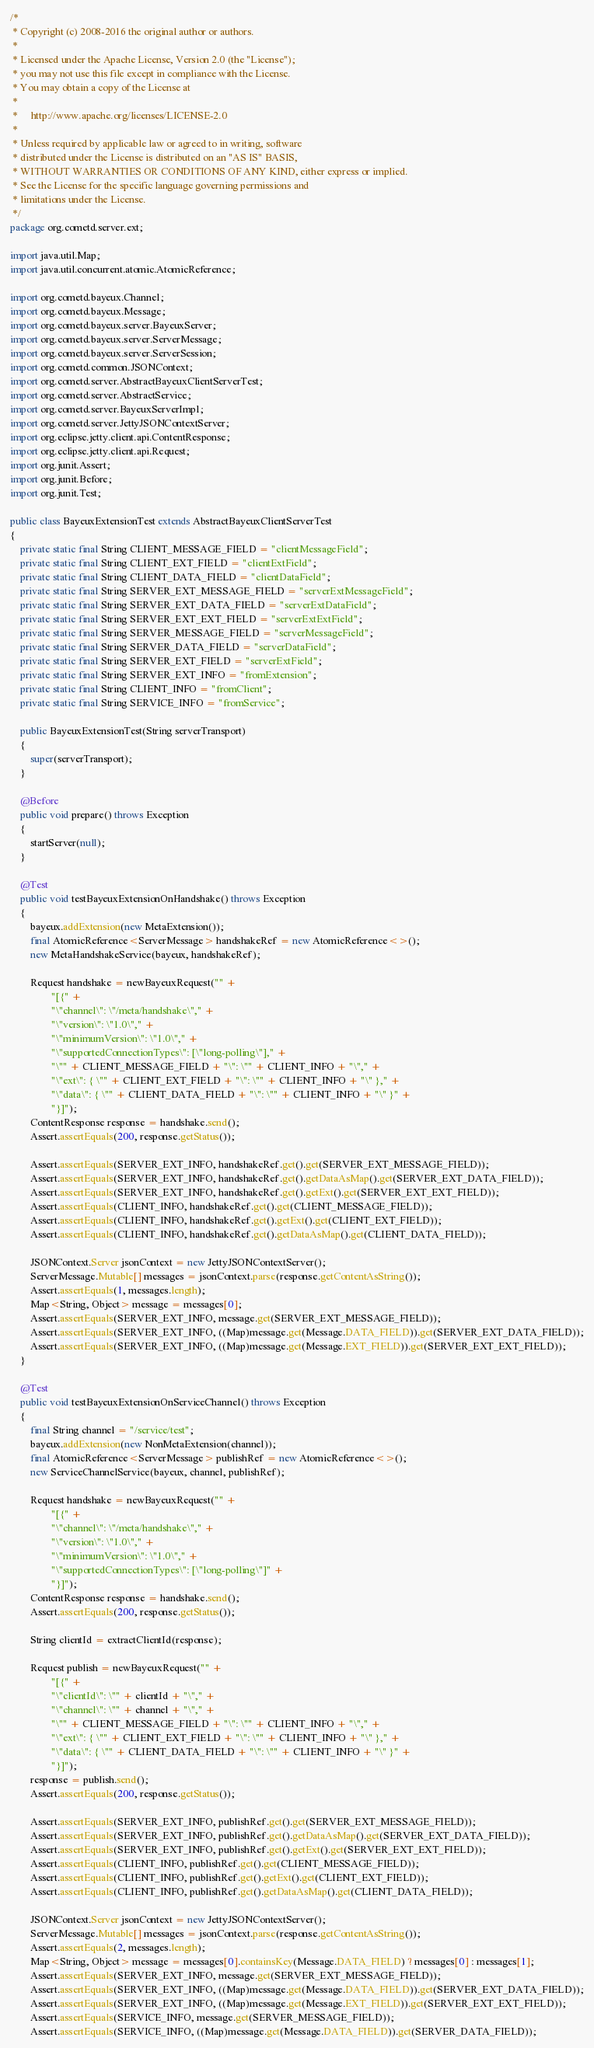Convert code to text. <code><loc_0><loc_0><loc_500><loc_500><_Java_>/*
 * Copyright (c) 2008-2016 the original author or authors.
 *
 * Licensed under the Apache License, Version 2.0 (the "License");
 * you may not use this file except in compliance with the License.
 * You may obtain a copy of the License at
 *
 *     http://www.apache.org/licenses/LICENSE-2.0
 *
 * Unless required by applicable law or agreed to in writing, software
 * distributed under the License is distributed on an "AS IS" BASIS,
 * WITHOUT WARRANTIES OR CONDITIONS OF ANY KIND, either express or implied.
 * See the License for the specific language governing permissions and
 * limitations under the License.
 */
package org.cometd.server.ext;

import java.util.Map;
import java.util.concurrent.atomic.AtomicReference;

import org.cometd.bayeux.Channel;
import org.cometd.bayeux.Message;
import org.cometd.bayeux.server.BayeuxServer;
import org.cometd.bayeux.server.ServerMessage;
import org.cometd.bayeux.server.ServerSession;
import org.cometd.common.JSONContext;
import org.cometd.server.AbstractBayeuxClientServerTest;
import org.cometd.server.AbstractService;
import org.cometd.server.BayeuxServerImpl;
import org.cometd.server.JettyJSONContextServer;
import org.eclipse.jetty.client.api.ContentResponse;
import org.eclipse.jetty.client.api.Request;
import org.junit.Assert;
import org.junit.Before;
import org.junit.Test;

public class BayeuxExtensionTest extends AbstractBayeuxClientServerTest
{
    private static final String CLIENT_MESSAGE_FIELD = "clientMessageField";
    private static final String CLIENT_EXT_FIELD = "clientExtField";
    private static final String CLIENT_DATA_FIELD = "clientDataField";
    private static final String SERVER_EXT_MESSAGE_FIELD = "serverExtMessageField";
    private static final String SERVER_EXT_DATA_FIELD = "serverExtDataField";
    private static final String SERVER_EXT_EXT_FIELD = "serverExtExtField";
    private static final String SERVER_MESSAGE_FIELD = "serverMessageField";
    private static final String SERVER_DATA_FIELD = "serverDataField";
    private static final String SERVER_EXT_FIELD = "serverExtField";
    private static final String SERVER_EXT_INFO = "fromExtension";
    private static final String CLIENT_INFO = "fromClient";
    private static final String SERVICE_INFO = "fromService";

    public BayeuxExtensionTest(String serverTransport)
    {
        super(serverTransport);
    }

    @Before
    public void prepare() throws Exception
    {
        startServer(null);
    }

    @Test
    public void testBayeuxExtensionOnHandshake() throws Exception
    {
        bayeux.addExtension(new MetaExtension());
        final AtomicReference<ServerMessage> handshakeRef = new AtomicReference<>();
        new MetaHandshakeService(bayeux, handshakeRef);

        Request handshake = newBayeuxRequest("" +
                "[{" +
                "\"channel\": \"/meta/handshake\"," +
                "\"version\": \"1.0\"," +
                "\"minimumVersion\": \"1.0\"," +
                "\"supportedConnectionTypes\": [\"long-polling\"]," +
                "\"" + CLIENT_MESSAGE_FIELD + "\": \"" + CLIENT_INFO + "\"," +
                "\"ext\": { \"" + CLIENT_EXT_FIELD + "\": \"" + CLIENT_INFO + "\" }," +
                "\"data\": { \"" + CLIENT_DATA_FIELD + "\": \"" + CLIENT_INFO + "\" }" +
                "}]");
        ContentResponse response = handshake.send();
        Assert.assertEquals(200, response.getStatus());

        Assert.assertEquals(SERVER_EXT_INFO, handshakeRef.get().get(SERVER_EXT_MESSAGE_FIELD));
        Assert.assertEquals(SERVER_EXT_INFO, handshakeRef.get().getDataAsMap().get(SERVER_EXT_DATA_FIELD));
        Assert.assertEquals(SERVER_EXT_INFO, handshakeRef.get().getExt().get(SERVER_EXT_EXT_FIELD));
        Assert.assertEquals(CLIENT_INFO, handshakeRef.get().get(CLIENT_MESSAGE_FIELD));
        Assert.assertEquals(CLIENT_INFO, handshakeRef.get().getExt().get(CLIENT_EXT_FIELD));
        Assert.assertEquals(CLIENT_INFO, handshakeRef.get().getDataAsMap().get(CLIENT_DATA_FIELD));

        JSONContext.Server jsonContext = new JettyJSONContextServer();
        ServerMessage.Mutable[] messages = jsonContext.parse(response.getContentAsString());
        Assert.assertEquals(1, messages.length);
        Map<String, Object> message = messages[0];
        Assert.assertEquals(SERVER_EXT_INFO, message.get(SERVER_EXT_MESSAGE_FIELD));
        Assert.assertEquals(SERVER_EXT_INFO, ((Map)message.get(Message.DATA_FIELD)).get(SERVER_EXT_DATA_FIELD));
        Assert.assertEquals(SERVER_EXT_INFO, ((Map)message.get(Message.EXT_FIELD)).get(SERVER_EXT_EXT_FIELD));
    }

    @Test
    public void testBayeuxExtensionOnServiceChannel() throws Exception
    {
        final String channel = "/service/test";
        bayeux.addExtension(new NonMetaExtension(channel));
        final AtomicReference<ServerMessage> publishRef = new AtomicReference<>();
        new ServiceChannelService(bayeux, channel, publishRef);

        Request handshake = newBayeuxRequest("" +
                "[{" +
                "\"channel\": \"/meta/handshake\"," +
                "\"version\": \"1.0\"," +
                "\"minimumVersion\": \"1.0\"," +
                "\"supportedConnectionTypes\": [\"long-polling\"]" +
                "}]");
        ContentResponse response = handshake.send();
        Assert.assertEquals(200, response.getStatus());

        String clientId = extractClientId(response);

        Request publish = newBayeuxRequest("" +
                "[{" +
                "\"clientId\": \"" + clientId + "\"," +
                "\"channel\": \"" + channel + "\"," +
                "\"" + CLIENT_MESSAGE_FIELD + "\": \"" + CLIENT_INFO + "\"," +
                "\"ext\": { \"" + CLIENT_EXT_FIELD + "\": \"" + CLIENT_INFO + "\" }," +
                "\"data\": { \"" + CLIENT_DATA_FIELD + "\": \"" + CLIENT_INFO + "\" }" +
                "}]");
        response = publish.send();
        Assert.assertEquals(200, response.getStatus());

        Assert.assertEquals(SERVER_EXT_INFO, publishRef.get().get(SERVER_EXT_MESSAGE_FIELD));
        Assert.assertEquals(SERVER_EXT_INFO, publishRef.get().getDataAsMap().get(SERVER_EXT_DATA_FIELD));
        Assert.assertEquals(SERVER_EXT_INFO, publishRef.get().getExt().get(SERVER_EXT_EXT_FIELD));
        Assert.assertEquals(CLIENT_INFO, publishRef.get().get(CLIENT_MESSAGE_FIELD));
        Assert.assertEquals(CLIENT_INFO, publishRef.get().getExt().get(CLIENT_EXT_FIELD));
        Assert.assertEquals(CLIENT_INFO, publishRef.get().getDataAsMap().get(CLIENT_DATA_FIELD));

        JSONContext.Server jsonContext = new JettyJSONContextServer();
        ServerMessage.Mutable[] messages = jsonContext.parse(response.getContentAsString());
        Assert.assertEquals(2, messages.length);
        Map<String, Object> message = messages[0].containsKey(Message.DATA_FIELD) ? messages[0] : messages[1];
        Assert.assertEquals(SERVER_EXT_INFO, message.get(SERVER_EXT_MESSAGE_FIELD));
        Assert.assertEquals(SERVER_EXT_INFO, ((Map)message.get(Message.DATA_FIELD)).get(SERVER_EXT_DATA_FIELD));
        Assert.assertEquals(SERVER_EXT_INFO, ((Map)message.get(Message.EXT_FIELD)).get(SERVER_EXT_EXT_FIELD));
        Assert.assertEquals(SERVICE_INFO, message.get(SERVER_MESSAGE_FIELD));
        Assert.assertEquals(SERVICE_INFO, ((Map)message.get(Message.DATA_FIELD)).get(SERVER_DATA_FIELD));</code> 